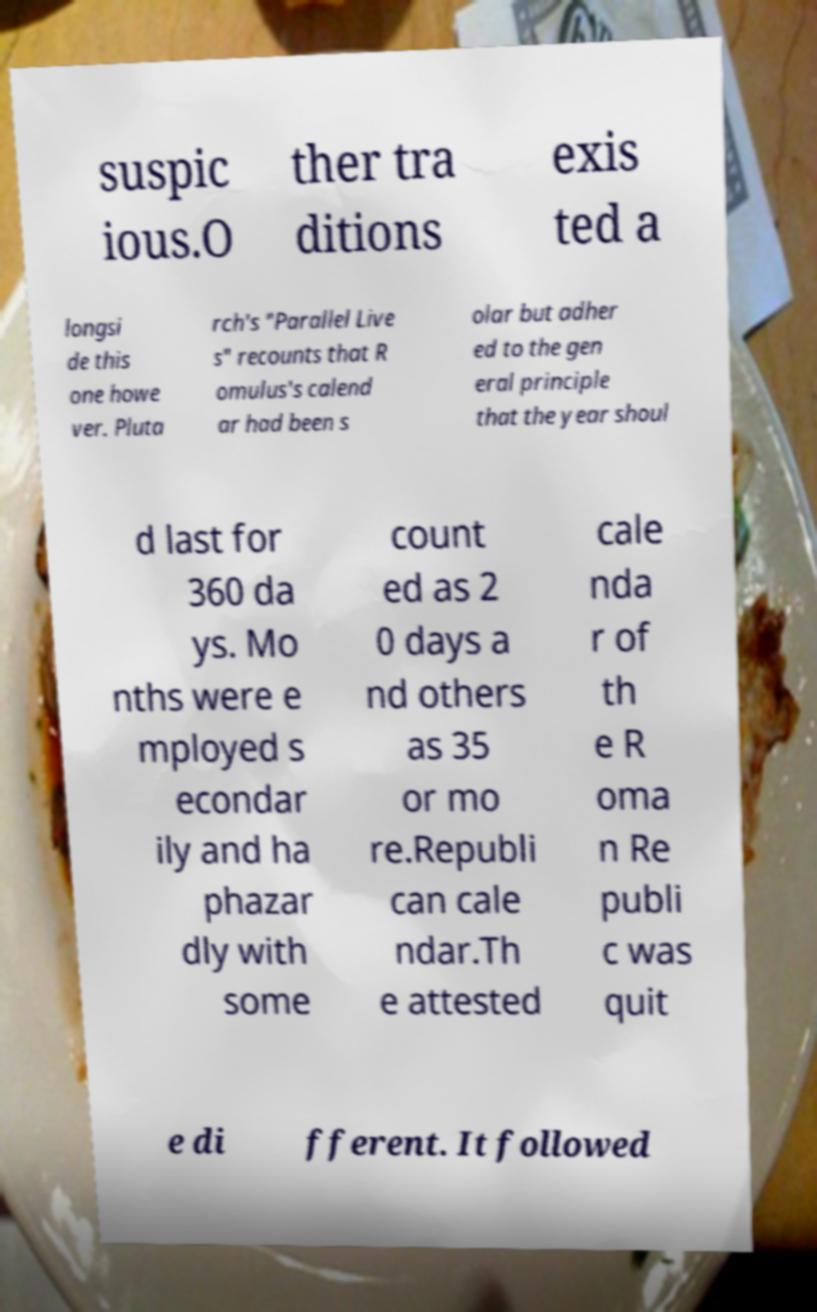Could you assist in decoding the text presented in this image and type it out clearly? suspic ious.O ther tra ditions exis ted a longsi de this one howe ver. Pluta rch's "Parallel Live s" recounts that R omulus's calend ar had been s olar but adher ed to the gen eral principle that the year shoul d last for 360 da ys. Mo nths were e mployed s econdar ily and ha phazar dly with some count ed as 2 0 days a nd others as 35 or mo re.Republi can cale ndar.Th e attested cale nda r of th e R oma n Re publi c was quit e di fferent. It followed 